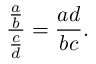<formula> <loc_0><loc_0><loc_500><loc_500>{ \frac { \frac { a } { b } } { \frac { c } { d } } } = { \frac { a d } { b c } } .</formula> 